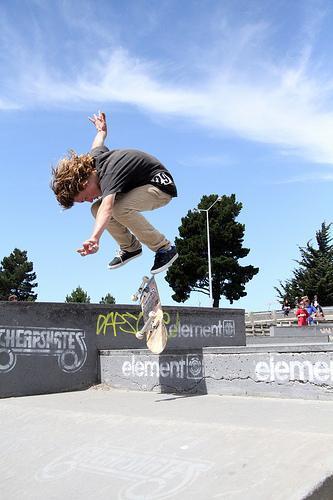How many people are in the air?
Give a very brief answer. 1. 